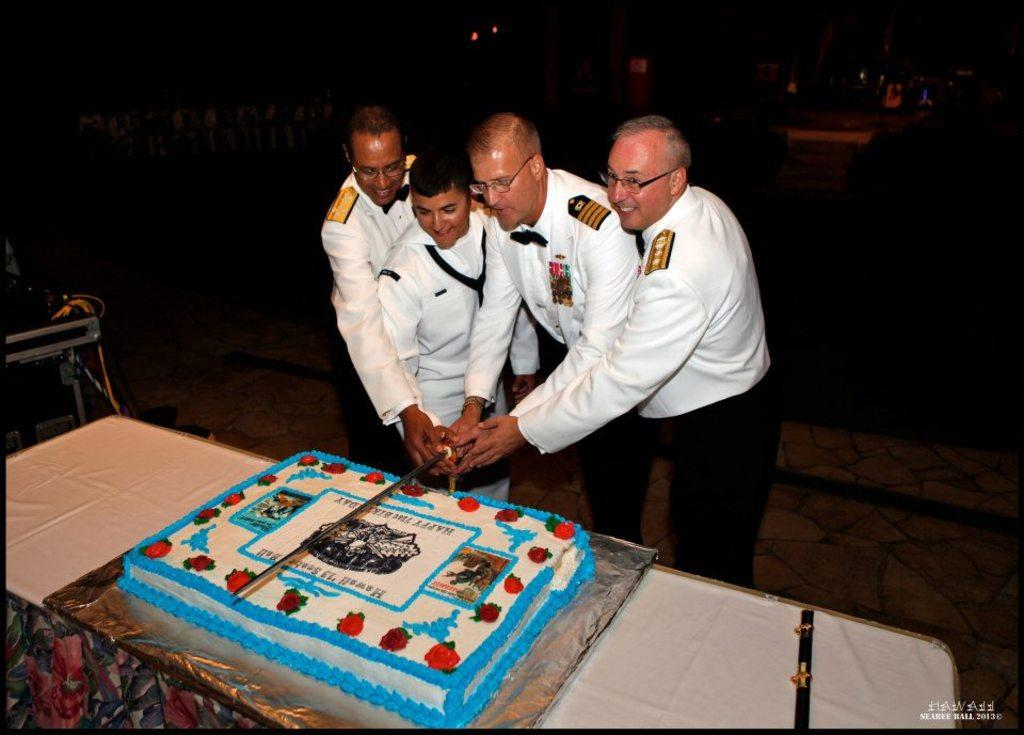How many people are present in the image? There are four people standing in the image. What are the people holding in their hands? The people are holding knives. What is the main object on the table in the image? There is a cake on a table. Can you describe any additional objects in the image? There are additional objects in the image, but their specific details are not mentioned in the provided facts. What is the lighting condition in the image? The background of the image is dark. What type of sound can be heard coming from the cake in the image? There is no sound coming from the cake in the image. What is the temper of the person holding the knife in the image? The provided facts do not give any information about the temper of the person holding the knife. 